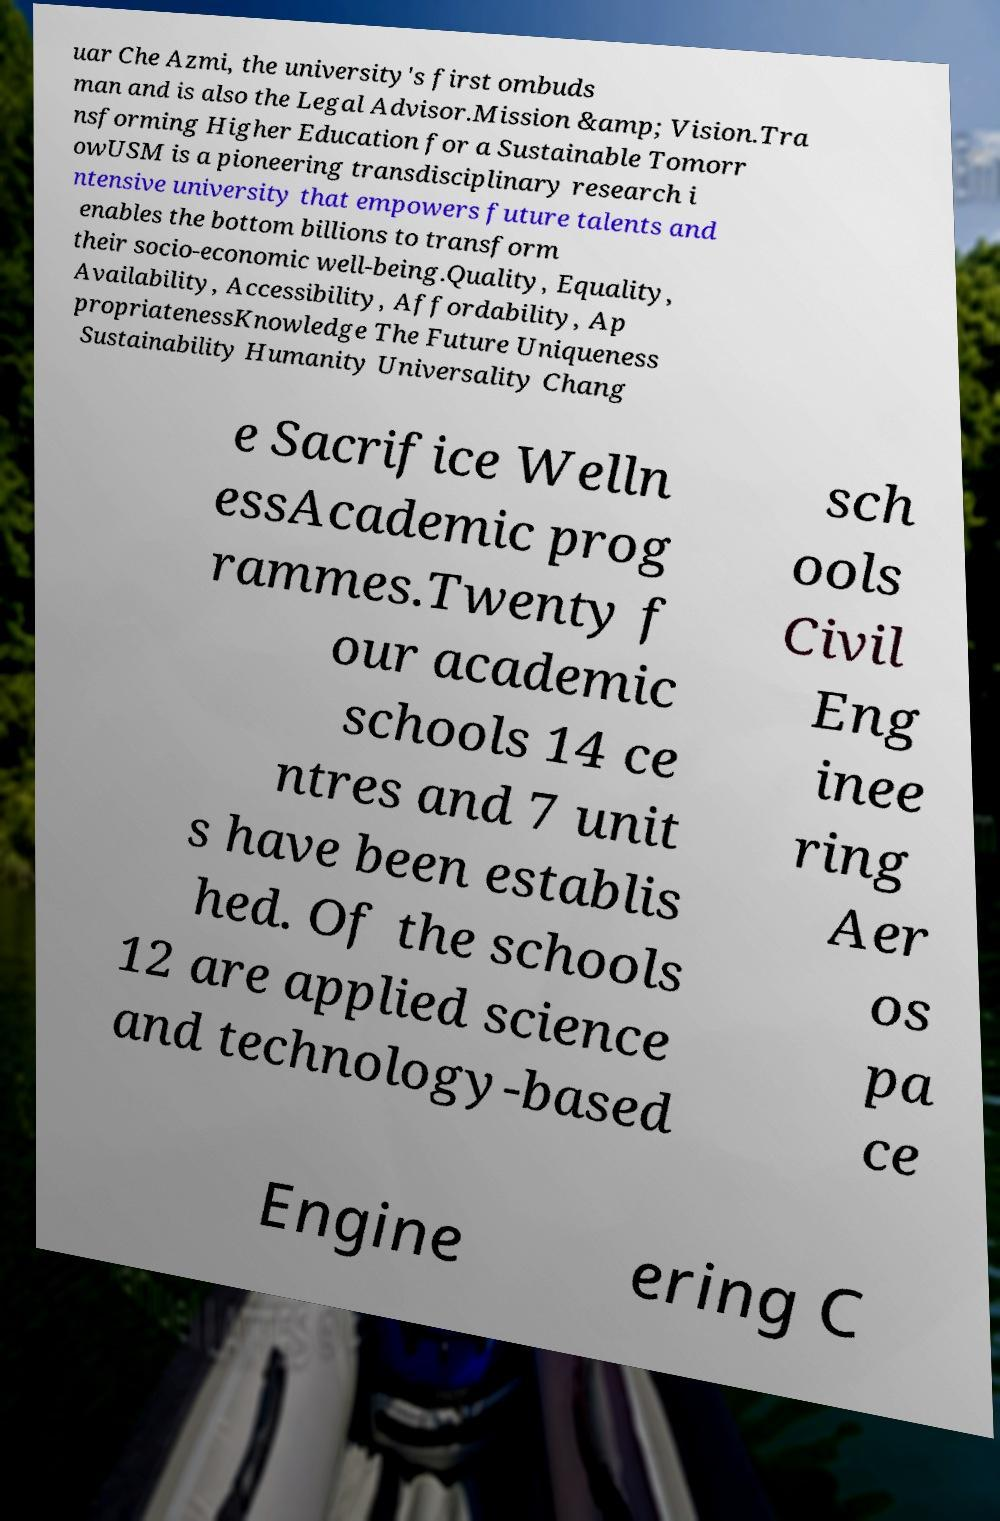Can you read and provide the text displayed in the image?This photo seems to have some interesting text. Can you extract and type it out for me? uar Che Azmi, the university's first ombuds man and is also the Legal Advisor.Mission &amp; Vision.Tra nsforming Higher Education for a Sustainable Tomorr owUSM is a pioneering transdisciplinary research i ntensive university that empowers future talents and enables the bottom billions to transform their socio-economic well-being.Quality, Equality, Availability, Accessibility, Affordability, Ap propriatenessKnowledge The Future Uniqueness Sustainability Humanity Universality Chang e Sacrifice Welln essAcademic prog rammes.Twenty f our academic schools 14 ce ntres and 7 unit s have been establis hed. Of the schools 12 are applied science and technology-based sch ools Civil Eng inee ring Aer os pa ce Engine ering C 